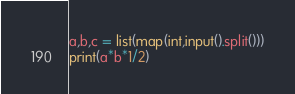Convert code to text. <code><loc_0><loc_0><loc_500><loc_500><_Python_>a,b,c = list(map(int,input().split()))
print(a*b*1/2)</code> 